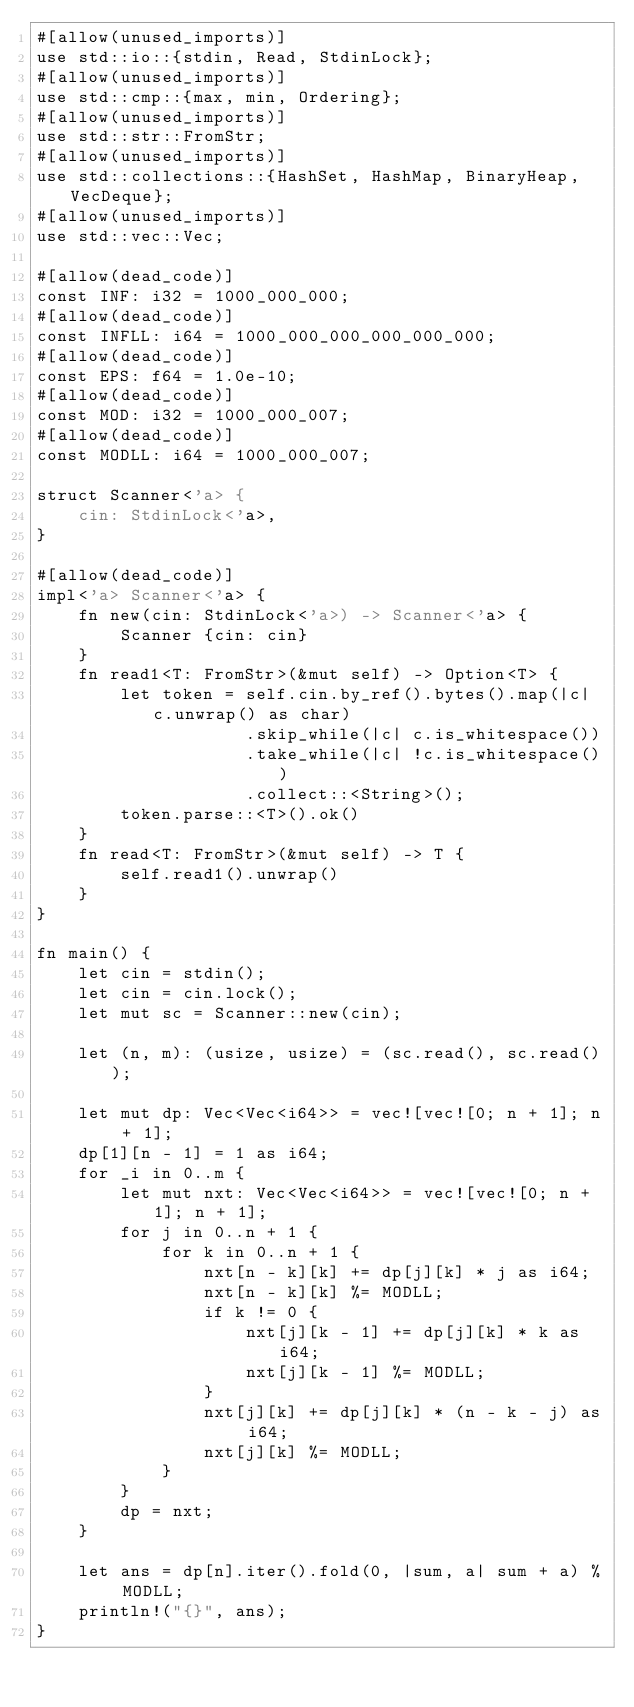Convert code to text. <code><loc_0><loc_0><loc_500><loc_500><_Rust_>#[allow(unused_imports)]
use std::io::{stdin, Read, StdinLock};
#[allow(unused_imports)]
use std::cmp::{max, min, Ordering};
#[allow(unused_imports)]
use std::str::FromStr;
#[allow(unused_imports)]
use std::collections::{HashSet, HashMap, BinaryHeap, VecDeque};
#[allow(unused_imports)]
use std::vec::Vec;

#[allow(dead_code)]
const INF: i32 = 1000_000_000;
#[allow(dead_code)]
const INFLL: i64 = 1000_000_000_000_000_000;
#[allow(dead_code)]
const EPS: f64 = 1.0e-10;
#[allow(dead_code)]
const MOD: i32 = 1000_000_007;
#[allow(dead_code)]
const MODLL: i64 = 1000_000_007;

struct Scanner<'a> {
    cin: StdinLock<'a>,
}

#[allow(dead_code)]
impl<'a> Scanner<'a> {
    fn new(cin: StdinLock<'a>) -> Scanner<'a> {
        Scanner {cin: cin}
    }
    fn read1<T: FromStr>(&mut self) -> Option<T> {
        let token = self.cin.by_ref().bytes().map(|c| c.unwrap() as char)
                    .skip_while(|c| c.is_whitespace())
                    .take_while(|c| !c.is_whitespace())
                    .collect::<String>();
        token.parse::<T>().ok()
    }
    fn read<T: FromStr>(&mut self) -> T {
        self.read1().unwrap()
    }
}

fn main() {
    let cin = stdin();
    let cin = cin.lock();
    let mut sc = Scanner::new(cin);

    let (n, m): (usize, usize) = (sc.read(), sc.read());

    let mut dp: Vec<Vec<i64>> = vec![vec![0; n + 1]; n + 1];
    dp[1][n - 1] = 1 as i64;
    for _i in 0..m {
        let mut nxt: Vec<Vec<i64>> = vec![vec![0; n + 1]; n + 1];
        for j in 0..n + 1 {
            for k in 0..n + 1 {
                nxt[n - k][k] += dp[j][k] * j as i64;
                nxt[n - k][k] %= MODLL;
                if k != 0 {
                    nxt[j][k - 1] += dp[j][k] * k as i64;
                    nxt[j][k - 1] %= MODLL;
                }
                nxt[j][k] += dp[j][k] * (n - k - j) as i64;
                nxt[j][k] %= MODLL;
            }
        }
        dp = nxt;
    }

    let ans = dp[n].iter().fold(0, |sum, a| sum + a) % MODLL;
    println!("{}", ans);
}</code> 